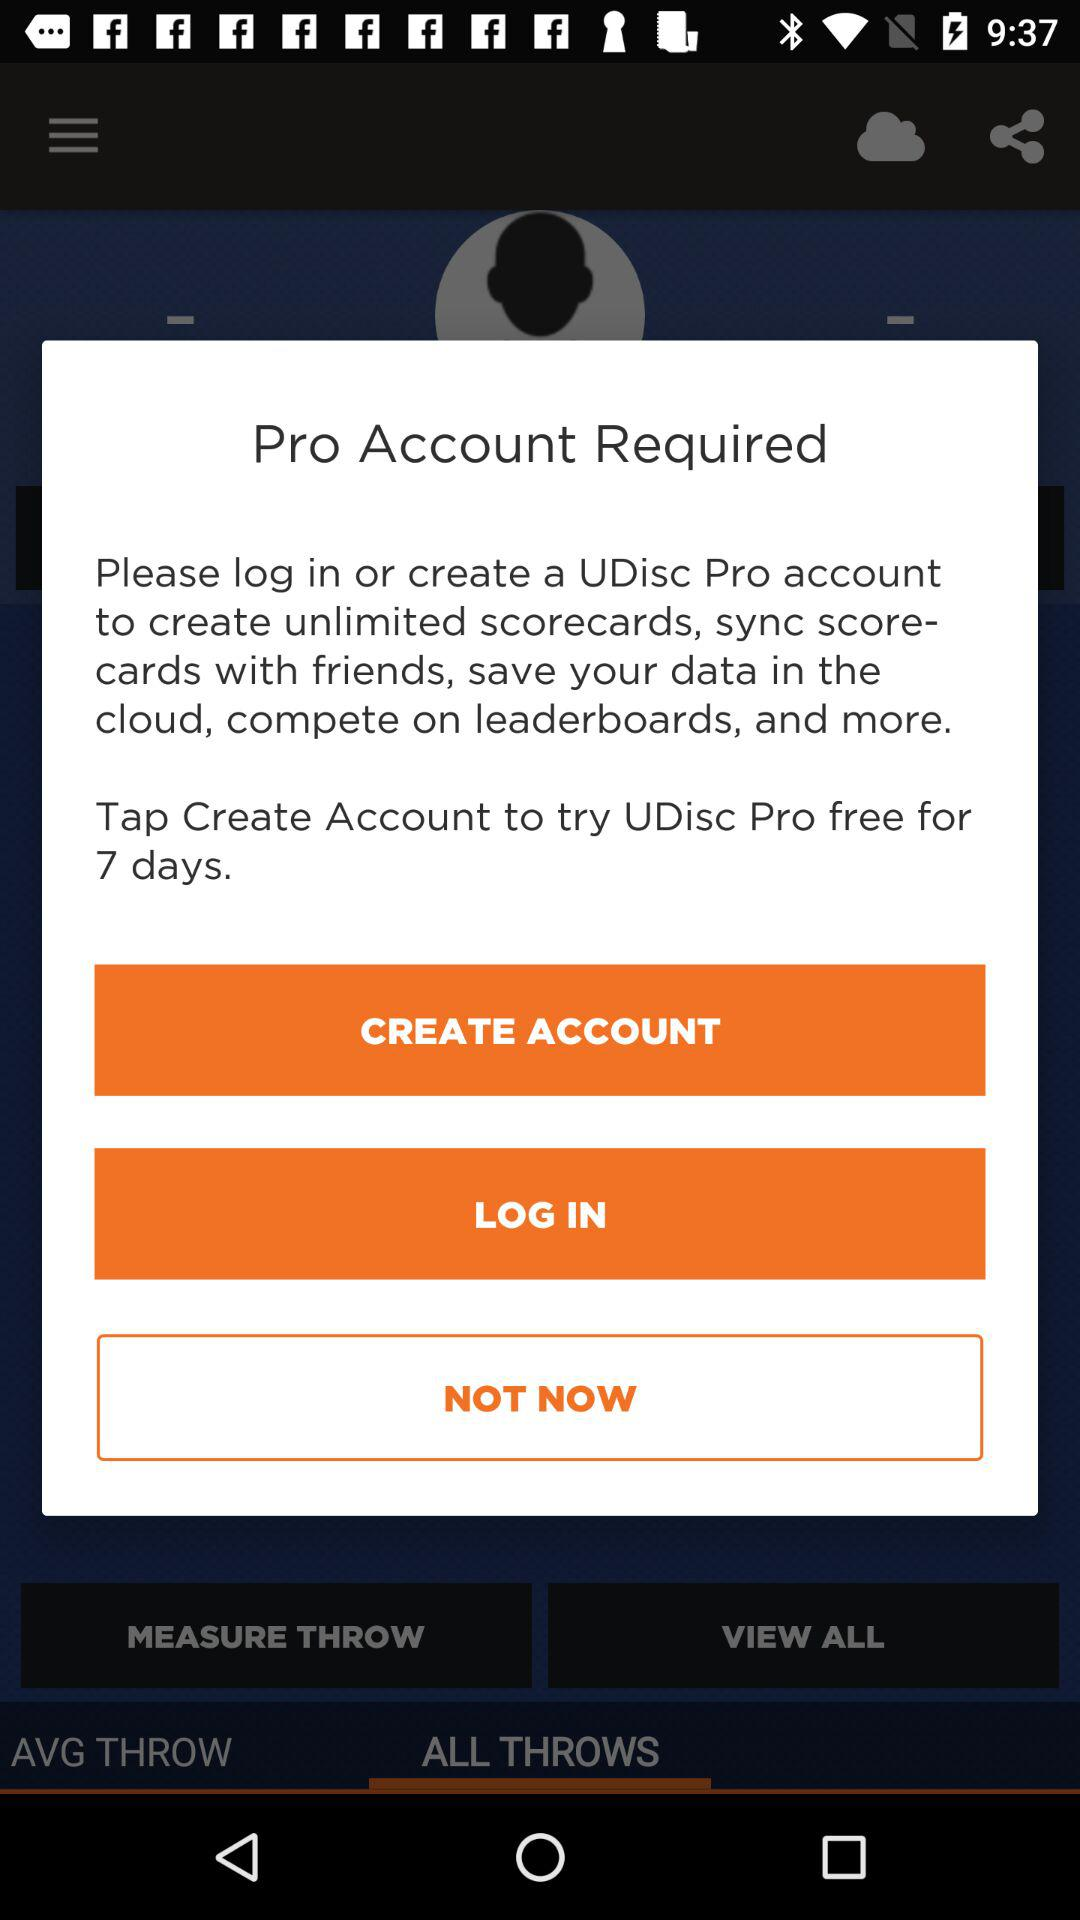For how many days is the free trial available? The free trial is available for 7 days. 